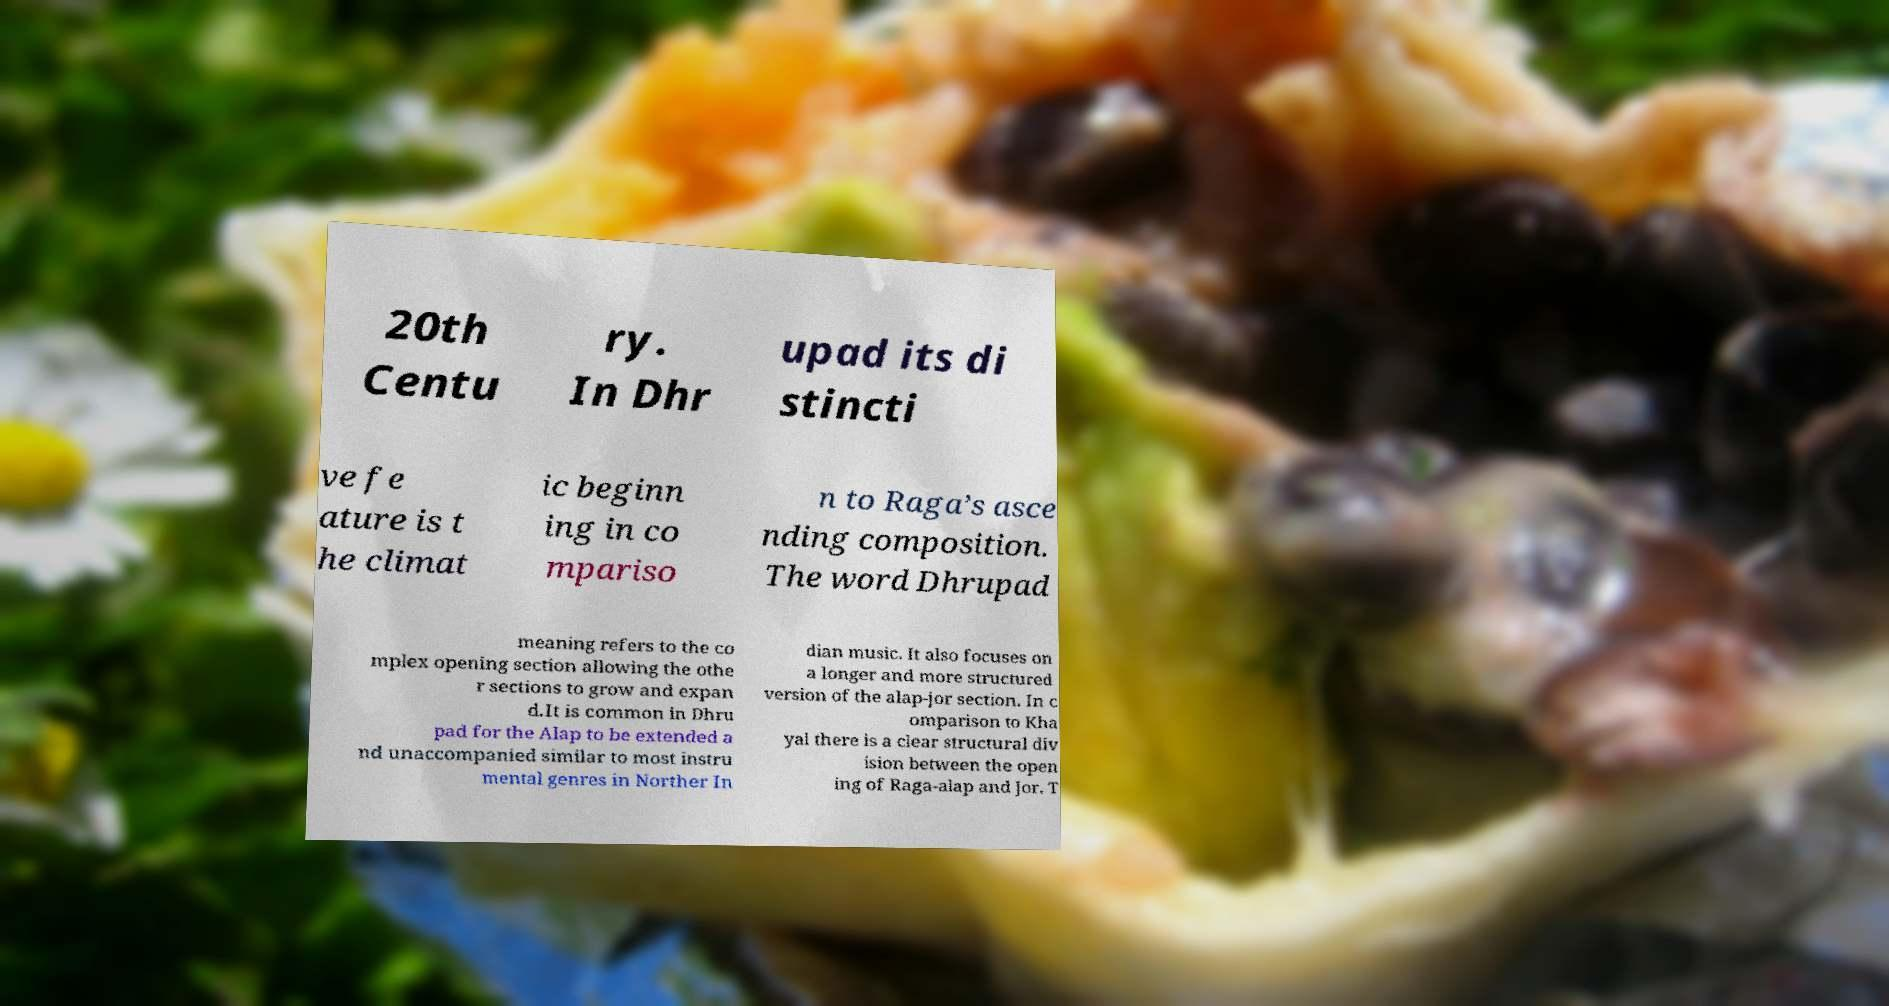Could you extract and type out the text from this image? 20th Centu ry. In Dhr upad its di stincti ve fe ature is t he climat ic beginn ing in co mpariso n to Raga’s asce nding composition. The word Dhrupad meaning refers to the co mplex opening section allowing the othe r sections to grow and expan d.It is common in Dhru pad for the Alap to be extended a nd unaccompanied similar to most instru mental genres in Norther In dian music. It also focuses on a longer and more structured version of the alap-jor section. In c omparison to Kha yal there is a clear structural div ision between the open ing of Raga-alap and Jor. T 